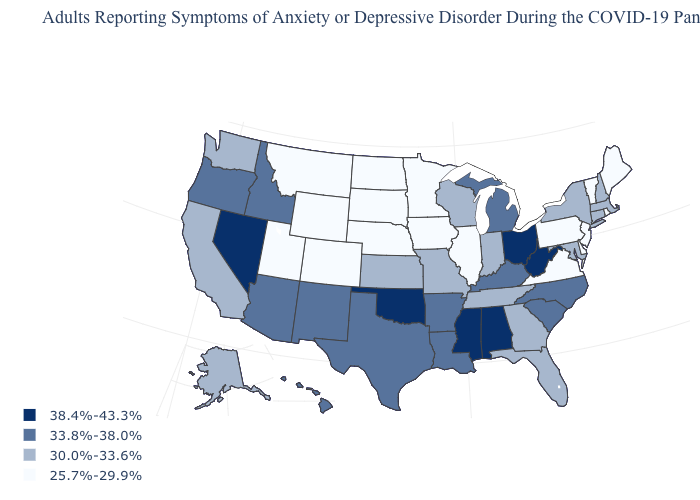Name the states that have a value in the range 30.0%-33.6%?
Give a very brief answer. Alaska, California, Connecticut, Florida, Georgia, Indiana, Kansas, Maryland, Massachusetts, Missouri, New Hampshire, New York, Tennessee, Washington, Wisconsin. What is the value of Tennessee?
Concise answer only. 30.0%-33.6%. Name the states that have a value in the range 25.7%-29.9%?
Answer briefly. Colorado, Delaware, Illinois, Iowa, Maine, Minnesota, Montana, Nebraska, New Jersey, North Dakota, Pennsylvania, Rhode Island, South Dakota, Utah, Vermont, Virginia, Wyoming. What is the value of Oregon?
Answer briefly. 33.8%-38.0%. What is the lowest value in states that border California?
Give a very brief answer. 33.8%-38.0%. Is the legend a continuous bar?
Write a very short answer. No. What is the value of Vermont?
Be succinct. 25.7%-29.9%. Name the states that have a value in the range 33.8%-38.0%?
Give a very brief answer. Arizona, Arkansas, Hawaii, Idaho, Kentucky, Louisiana, Michigan, New Mexico, North Carolina, Oregon, South Carolina, Texas. What is the lowest value in states that border New Hampshire?
Short answer required. 25.7%-29.9%. Name the states that have a value in the range 30.0%-33.6%?
Be succinct. Alaska, California, Connecticut, Florida, Georgia, Indiana, Kansas, Maryland, Massachusetts, Missouri, New Hampshire, New York, Tennessee, Washington, Wisconsin. Among the states that border Kansas , which have the highest value?
Keep it brief. Oklahoma. Name the states that have a value in the range 33.8%-38.0%?
Keep it brief. Arizona, Arkansas, Hawaii, Idaho, Kentucky, Louisiana, Michigan, New Mexico, North Carolina, Oregon, South Carolina, Texas. How many symbols are there in the legend?
Be succinct. 4. What is the lowest value in the USA?
Quick response, please. 25.7%-29.9%. Does Alabama have the highest value in the USA?
Be succinct. Yes. 